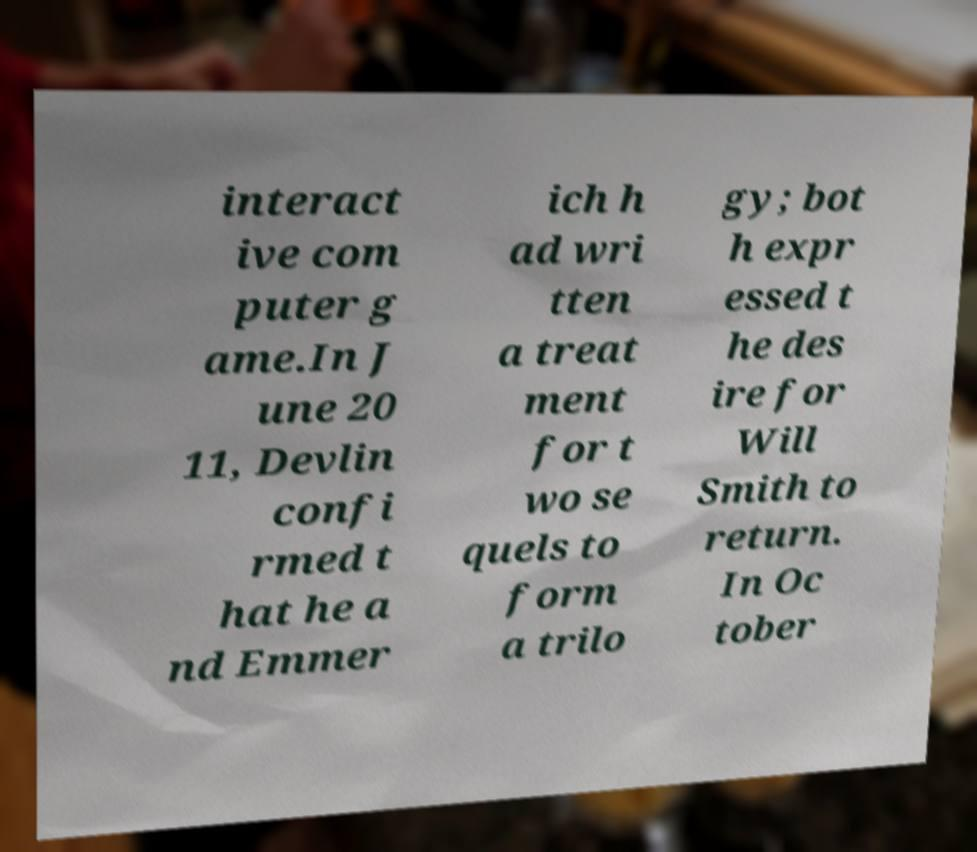Please read and relay the text visible in this image. What does it say? interact ive com puter g ame.In J une 20 11, Devlin confi rmed t hat he a nd Emmer ich h ad wri tten a treat ment for t wo se quels to form a trilo gy; bot h expr essed t he des ire for Will Smith to return. In Oc tober 